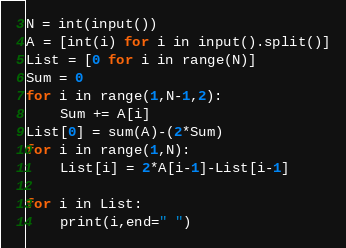<code> <loc_0><loc_0><loc_500><loc_500><_Python_>N = int(input())
A = [int(i) for i in input().split()]
List = [0 for i in range(N)]
Sum = 0
for i in range(1,N-1,2):
    Sum += A[i]
List[0] = sum(A)-(2*Sum)
for i in range(1,N):
    List[i] = 2*A[i-1]-List[i-1]

for i in List:
    print(i,end=" ")</code> 